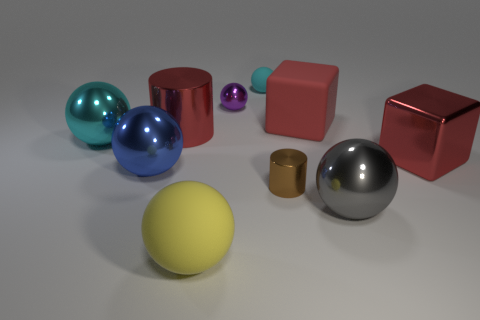Subtract 3 balls. How many balls are left? 3 Subtract all purple balls. How many balls are left? 5 Subtract all purple balls. How many balls are left? 5 Subtract all red balls. Subtract all gray cylinders. How many balls are left? 6 Subtract all spheres. How many objects are left? 4 Subtract 0 green cubes. How many objects are left? 10 Subtract all gray shiny objects. Subtract all tiny purple cylinders. How many objects are left? 9 Add 6 big blue shiny objects. How many big blue shiny objects are left? 7 Add 5 large rubber objects. How many large rubber objects exist? 7 